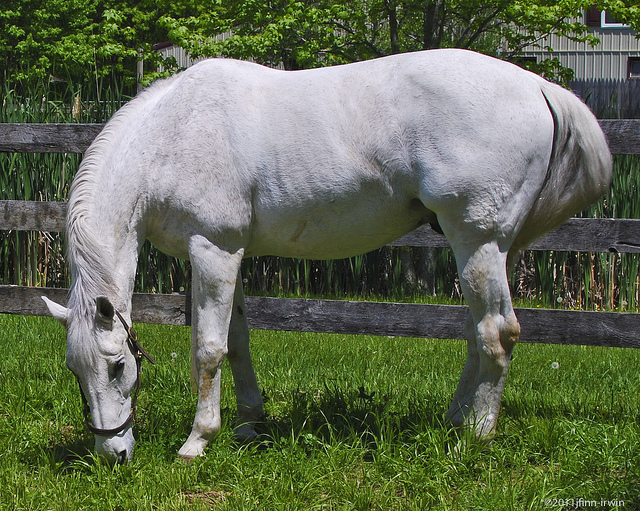What is the horse doing? The horse is peacefully grazing on the grass in a relaxed manner. 